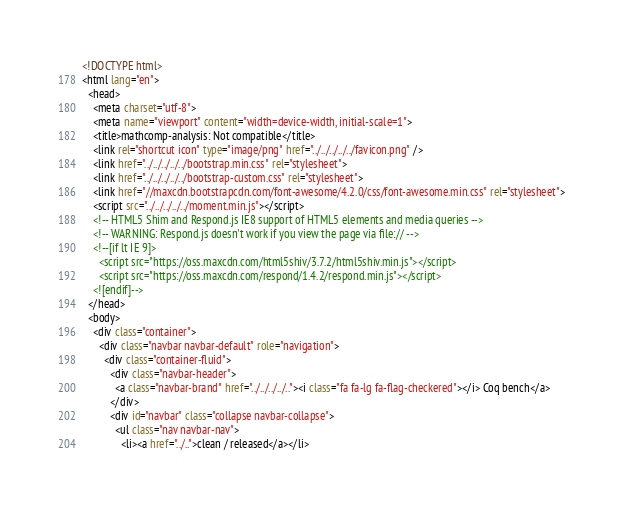<code> <loc_0><loc_0><loc_500><loc_500><_HTML_><!DOCTYPE html>
<html lang="en">
  <head>
    <meta charset="utf-8">
    <meta name="viewport" content="width=device-width, initial-scale=1">
    <title>mathcomp-analysis: Not compatible</title>
    <link rel="shortcut icon" type="image/png" href="../../../../../favicon.png" />
    <link href="../../../../../bootstrap.min.css" rel="stylesheet">
    <link href="../../../../../bootstrap-custom.css" rel="stylesheet">
    <link href="//maxcdn.bootstrapcdn.com/font-awesome/4.2.0/css/font-awesome.min.css" rel="stylesheet">
    <script src="../../../../../moment.min.js"></script>
    <!-- HTML5 Shim and Respond.js IE8 support of HTML5 elements and media queries -->
    <!-- WARNING: Respond.js doesn't work if you view the page via file:// -->
    <!--[if lt IE 9]>
      <script src="https://oss.maxcdn.com/html5shiv/3.7.2/html5shiv.min.js"></script>
      <script src="https://oss.maxcdn.com/respond/1.4.2/respond.min.js"></script>
    <![endif]-->
  </head>
  <body>
    <div class="container">
      <div class="navbar navbar-default" role="navigation">
        <div class="container-fluid">
          <div class="navbar-header">
            <a class="navbar-brand" href="../../../../.."><i class="fa fa-lg fa-flag-checkered"></i> Coq bench</a>
          </div>
          <div id="navbar" class="collapse navbar-collapse">
            <ul class="nav navbar-nav">
              <li><a href="../..">clean / released</a></li></code> 